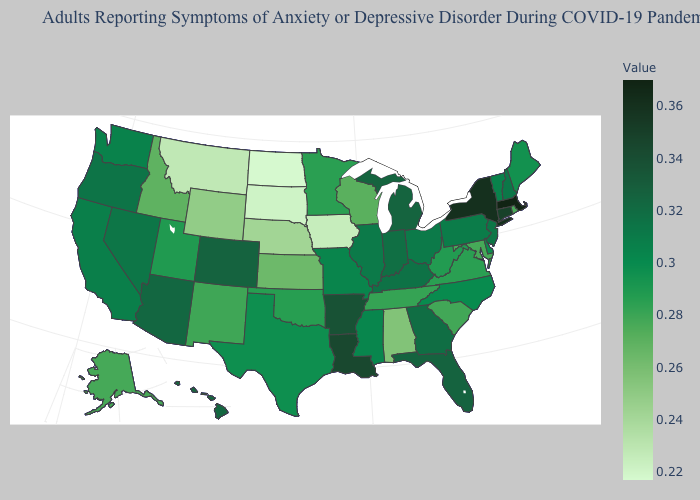Which states hav the highest value in the MidWest?
Give a very brief answer. Michigan. Which states have the lowest value in the USA?
Short answer required. North Dakota. Which states have the lowest value in the USA?
Write a very short answer. North Dakota. 